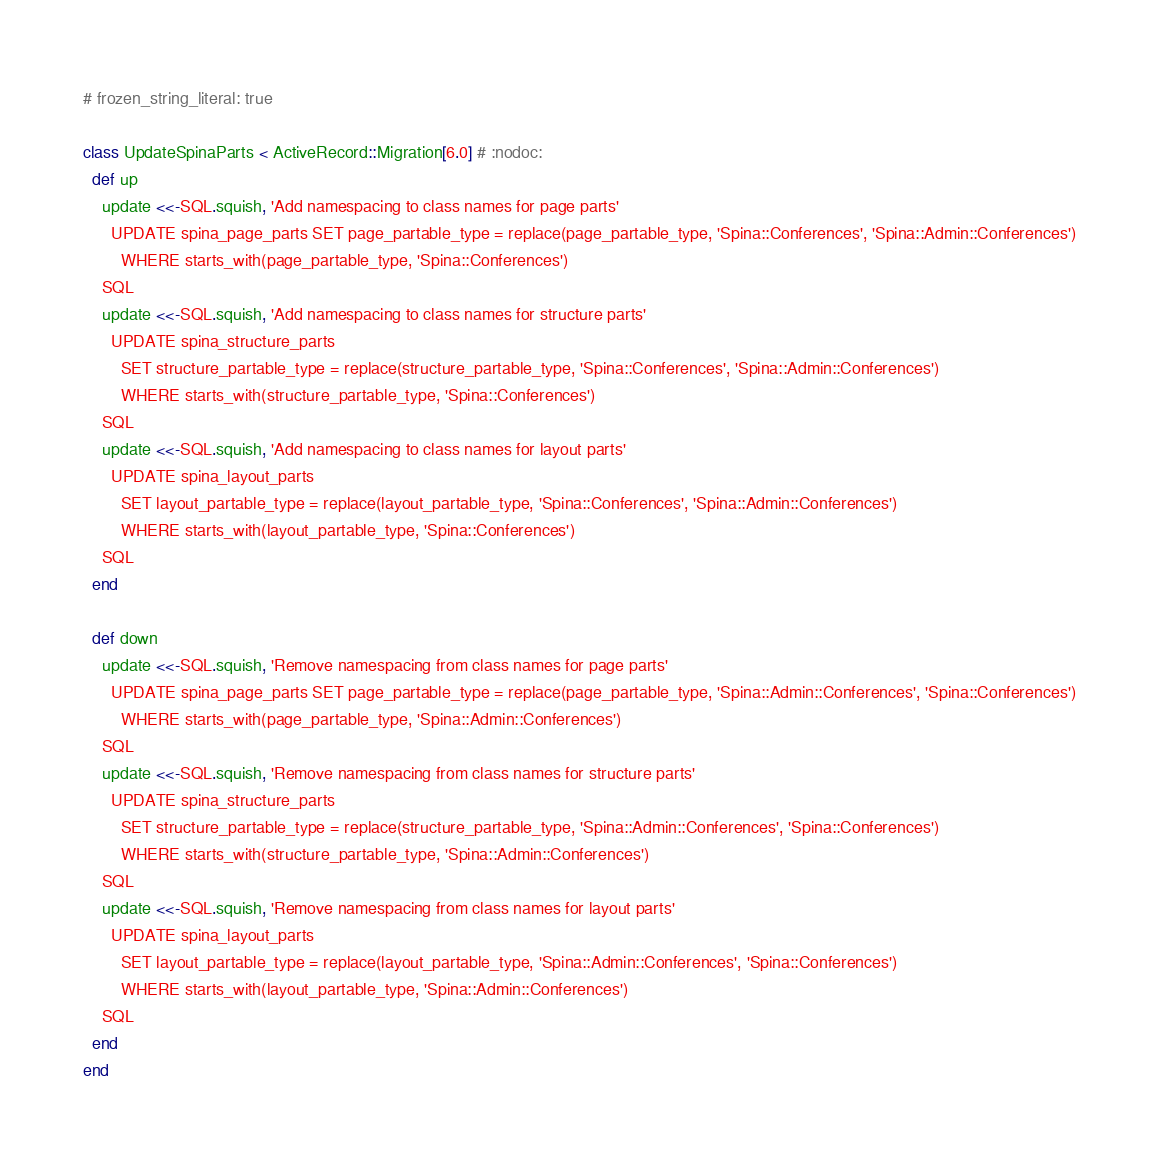Convert code to text. <code><loc_0><loc_0><loc_500><loc_500><_Ruby_># frozen_string_literal: true

class UpdateSpinaParts < ActiveRecord::Migration[6.0] # :nodoc:
  def up
    update <<-SQL.squish, 'Add namespacing to class names for page parts'
      UPDATE spina_page_parts SET page_partable_type = replace(page_partable_type, 'Spina::Conferences', 'Spina::Admin::Conferences')
        WHERE starts_with(page_partable_type, 'Spina::Conferences')
    SQL
    update <<-SQL.squish, 'Add namespacing to class names for structure parts'
      UPDATE spina_structure_parts
        SET structure_partable_type = replace(structure_partable_type, 'Spina::Conferences', 'Spina::Admin::Conferences')
        WHERE starts_with(structure_partable_type, 'Spina::Conferences')
    SQL
    update <<-SQL.squish, 'Add namespacing to class names for layout parts'
      UPDATE spina_layout_parts
        SET layout_partable_type = replace(layout_partable_type, 'Spina::Conferences', 'Spina::Admin::Conferences')
        WHERE starts_with(layout_partable_type, 'Spina::Conferences')
    SQL
  end

  def down
    update <<-SQL.squish, 'Remove namespacing from class names for page parts'
      UPDATE spina_page_parts SET page_partable_type = replace(page_partable_type, 'Spina::Admin::Conferences', 'Spina::Conferences')
        WHERE starts_with(page_partable_type, 'Spina::Admin::Conferences')
    SQL
    update <<-SQL.squish, 'Remove namespacing from class names for structure parts'
      UPDATE spina_structure_parts
        SET structure_partable_type = replace(structure_partable_type, 'Spina::Admin::Conferences', 'Spina::Conferences')
        WHERE starts_with(structure_partable_type, 'Spina::Admin::Conferences')
    SQL
    update <<-SQL.squish, 'Remove namespacing from class names for layout parts'
      UPDATE spina_layout_parts
        SET layout_partable_type = replace(layout_partable_type, 'Spina::Admin::Conferences', 'Spina::Conferences')
        WHERE starts_with(layout_partable_type, 'Spina::Admin::Conferences')
    SQL
  end
end
</code> 